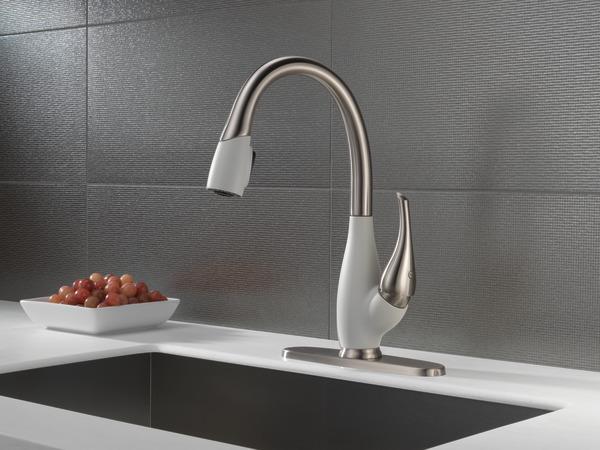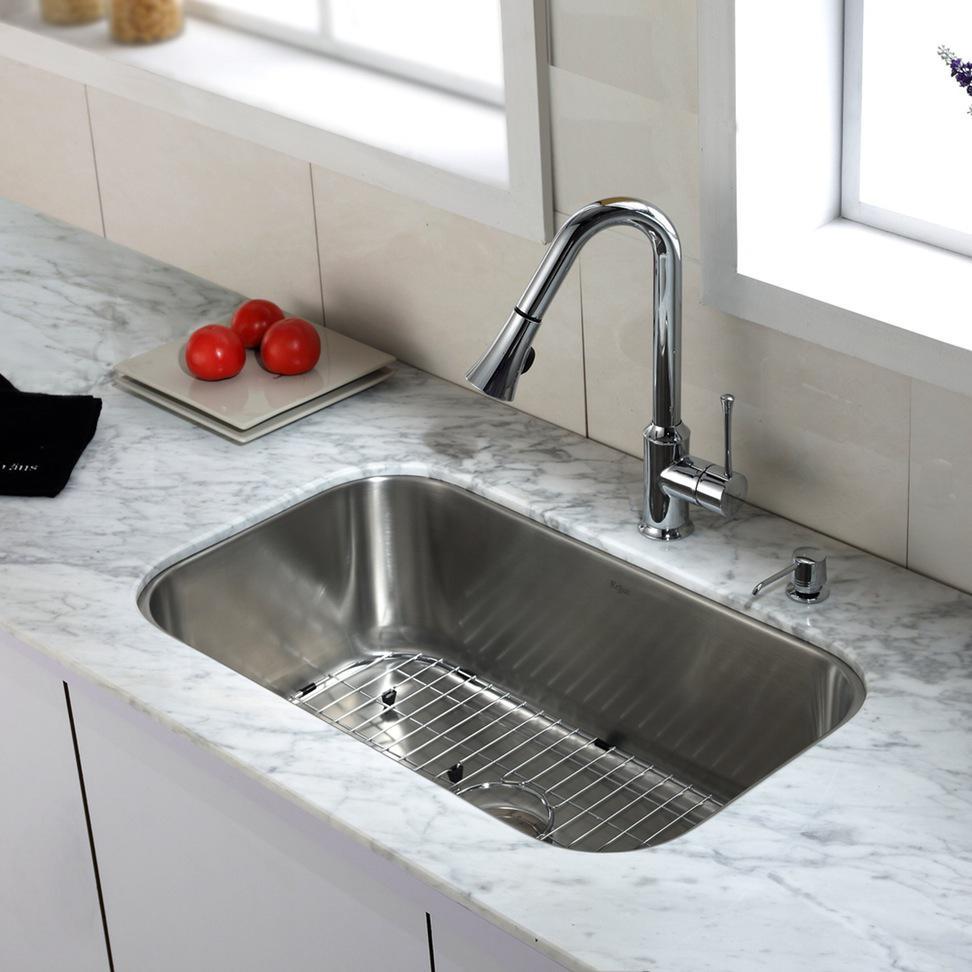The first image is the image on the left, the second image is the image on the right. Analyze the images presented: Is the assertion "The sink in the image on the right has a double basin." valid? Answer yes or no. No. The first image is the image on the left, the second image is the image on the right. Considering the images on both sides, is "An image shows a single-basin steel sink with a wire rack insert, inset in a gray swirl marble counter." valid? Answer yes or no. Yes. 